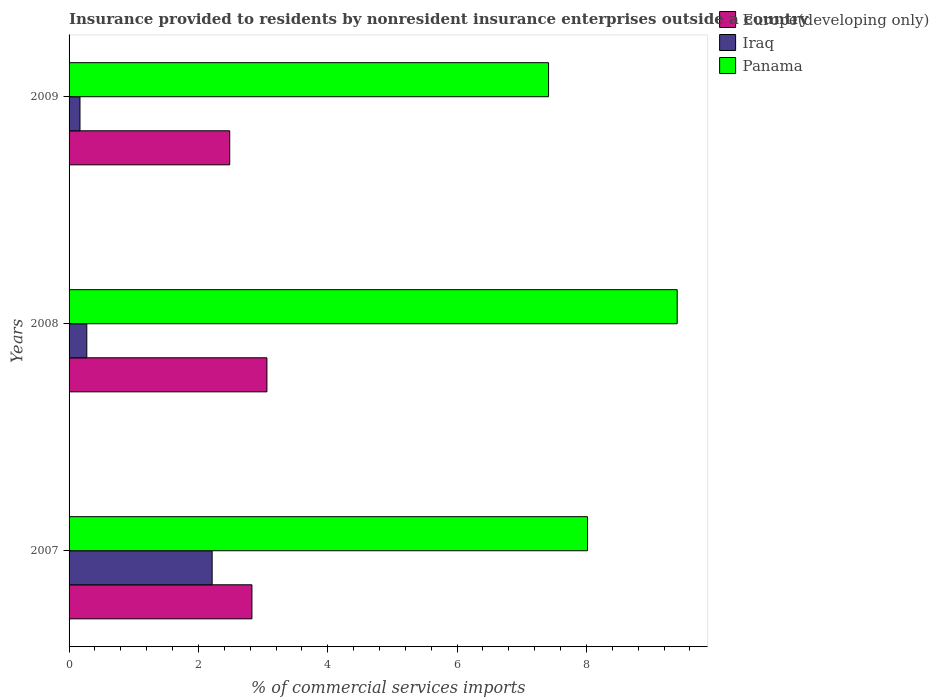How many different coloured bars are there?
Offer a very short reply. 3. Are the number of bars on each tick of the Y-axis equal?
Offer a terse response. Yes. How many bars are there on the 2nd tick from the top?
Make the answer very short. 3. What is the Insurance provided to residents in Panama in 2008?
Offer a very short reply. 9.4. Across all years, what is the maximum Insurance provided to residents in Europe(developing only)?
Keep it short and to the point. 3.06. Across all years, what is the minimum Insurance provided to residents in Panama?
Ensure brevity in your answer.  7.41. In which year was the Insurance provided to residents in Iraq maximum?
Offer a terse response. 2007. In which year was the Insurance provided to residents in Europe(developing only) minimum?
Your answer should be compact. 2009. What is the total Insurance provided to residents in Panama in the graph?
Provide a short and direct response. 24.83. What is the difference between the Insurance provided to residents in Iraq in 2007 and that in 2009?
Keep it short and to the point. 2.04. What is the difference between the Insurance provided to residents in Panama in 2009 and the Insurance provided to residents in Iraq in 2007?
Ensure brevity in your answer.  5.2. What is the average Insurance provided to residents in Iraq per year?
Make the answer very short. 0.88. In the year 2008, what is the difference between the Insurance provided to residents in Panama and Insurance provided to residents in Europe(developing only)?
Your response must be concise. 6.34. What is the ratio of the Insurance provided to residents in Panama in 2008 to that in 2009?
Your response must be concise. 1.27. Is the difference between the Insurance provided to residents in Panama in 2008 and 2009 greater than the difference between the Insurance provided to residents in Europe(developing only) in 2008 and 2009?
Make the answer very short. Yes. What is the difference between the highest and the second highest Insurance provided to residents in Europe(developing only)?
Give a very brief answer. 0.23. What is the difference between the highest and the lowest Insurance provided to residents in Panama?
Your answer should be compact. 1.99. In how many years, is the Insurance provided to residents in Panama greater than the average Insurance provided to residents in Panama taken over all years?
Ensure brevity in your answer.  1. What does the 2nd bar from the top in 2009 represents?
Your response must be concise. Iraq. What does the 2nd bar from the bottom in 2008 represents?
Provide a succinct answer. Iraq. Are all the bars in the graph horizontal?
Your answer should be very brief. Yes. How many years are there in the graph?
Your response must be concise. 3. What is the difference between two consecutive major ticks on the X-axis?
Keep it short and to the point. 2. What is the title of the graph?
Your response must be concise. Insurance provided to residents by nonresident insurance enterprises outside a country. Does "North America" appear as one of the legend labels in the graph?
Make the answer very short. No. What is the label or title of the X-axis?
Provide a short and direct response. % of commercial services imports. What is the label or title of the Y-axis?
Make the answer very short. Years. What is the % of commercial services imports of Europe(developing only) in 2007?
Ensure brevity in your answer.  2.83. What is the % of commercial services imports of Iraq in 2007?
Ensure brevity in your answer.  2.21. What is the % of commercial services imports in Panama in 2007?
Ensure brevity in your answer.  8.02. What is the % of commercial services imports of Europe(developing only) in 2008?
Give a very brief answer. 3.06. What is the % of commercial services imports of Iraq in 2008?
Your answer should be compact. 0.27. What is the % of commercial services imports in Panama in 2008?
Your response must be concise. 9.4. What is the % of commercial services imports of Europe(developing only) in 2009?
Keep it short and to the point. 2.48. What is the % of commercial services imports of Iraq in 2009?
Offer a very short reply. 0.17. What is the % of commercial services imports of Panama in 2009?
Offer a very short reply. 7.41. Across all years, what is the maximum % of commercial services imports in Europe(developing only)?
Make the answer very short. 3.06. Across all years, what is the maximum % of commercial services imports in Iraq?
Your answer should be very brief. 2.21. Across all years, what is the maximum % of commercial services imports in Panama?
Your answer should be compact. 9.4. Across all years, what is the minimum % of commercial services imports of Europe(developing only)?
Your answer should be very brief. 2.48. Across all years, what is the minimum % of commercial services imports of Iraq?
Provide a succinct answer. 0.17. Across all years, what is the minimum % of commercial services imports of Panama?
Your answer should be very brief. 7.41. What is the total % of commercial services imports in Europe(developing only) in the graph?
Ensure brevity in your answer.  8.37. What is the total % of commercial services imports of Iraq in the graph?
Give a very brief answer. 2.65. What is the total % of commercial services imports in Panama in the graph?
Provide a succinct answer. 24.83. What is the difference between the % of commercial services imports of Europe(developing only) in 2007 and that in 2008?
Make the answer very short. -0.23. What is the difference between the % of commercial services imports in Iraq in 2007 and that in 2008?
Provide a succinct answer. 1.94. What is the difference between the % of commercial services imports of Panama in 2007 and that in 2008?
Give a very brief answer. -1.39. What is the difference between the % of commercial services imports in Europe(developing only) in 2007 and that in 2009?
Give a very brief answer. 0.34. What is the difference between the % of commercial services imports of Iraq in 2007 and that in 2009?
Offer a terse response. 2.04. What is the difference between the % of commercial services imports in Panama in 2007 and that in 2009?
Keep it short and to the point. 0.6. What is the difference between the % of commercial services imports in Europe(developing only) in 2008 and that in 2009?
Keep it short and to the point. 0.58. What is the difference between the % of commercial services imports of Iraq in 2008 and that in 2009?
Provide a succinct answer. 0.11. What is the difference between the % of commercial services imports in Panama in 2008 and that in 2009?
Provide a short and direct response. 1.99. What is the difference between the % of commercial services imports in Europe(developing only) in 2007 and the % of commercial services imports in Iraq in 2008?
Ensure brevity in your answer.  2.55. What is the difference between the % of commercial services imports of Europe(developing only) in 2007 and the % of commercial services imports of Panama in 2008?
Make the answer very short. -6.58. What is the difference between the % of commercial services imports in Iraq in 2007 and the % of commercial services imports in Panama in 2008?
Keep it short and to the point. -7.19. What is the difference between the % of commercial services imports in Europe(developing only) in 2007 and the % of commercial services imports in Iraq in 2009?
Ensure brevity in your answer.  2.66. What is the difference between the % of commercial services imports of Europe(developing only) in 2007 and the % of commercial services imports of Panama in 2009?
Provide a short and direct response. -4.59. What is the difference between the % of commercial services imports in Iraq in 2007 and the % of commercial services imports in Panama in 2009?
Provide a succinct answer. -5.2. What is the difference between the % of commercial services imports of Europe(developing only) in 2008 and the % of commercial services imports of Iraq in 2009?
Give a very brief answer. 2.89. What is the difference between the % of commercial services imports of Europe(developing only) in 2008 and the % of commercial services imports of Panama in 2009?
Your answer should be compact. -4.35. What is the difference between the % of commercial services imports in Iraq in 2008 and the % of commercial services imports in Panama in 2009?
Offer a terse response. -7.14. What is the average % of commercial services imports in Europe(developing only) per year?
Your answer should be very brief. 2.79. What is the average % of commercial services imports in Iraq per year?
Offer a terse response. 0.89. What is the average % of commercial services imports of Panama per year?
Your answer should be very brief. 8.28. In the year 2007, what is the difference between the % of commercial services imports of Europe(developing only) and % of commercial services imports of Iraq?
Keep it short and to the point. 0.62. In the year 2007, what is the difference between the % of commercial services imports in Europe(developing only) and % of commercial services imports in Panama?
Your answer should be compact. -5.19. In the year 2007, what is the difference between the % of commercial services imports of Iraq and % of commercial services imports of Panama?
Keep it short and to the point. -5.8. In the year 2008, what is the difference between the % of commercial services imports in Europe(developing only) and % of commercial services imports in Iraq?
Offer a terse response. 2.79. In the year 2008, what is the difference between the % of commercial services imports of Europe(developing only) and % of commercial services imports of Panama?
Offer a terse response. -6.34. In the year 2008, what is the difference between the % of commercial services imports of Iraq and % of commercial services imports of Panama?
Your answer should be very brief. -9.13. In the year 2009, what is the difference between the % of commercial services imports of Europe(developing only) and % of commercial services imports of Iraq?
Make the answer very short. 2.32. In the year 2009, what is the difference between the % of commercial services imports of Europe(developing only) and % of commercial services imports of Panama?
Ensure brevity in your answer.  -4.93. In the year 2009, what is the difference between the % of commercial services imports of Iraq and % of commercial services imports of Panama?
Make the answer very short. -7.25. What is the ratio of the % of commercial services imports in Europe(developing only) in 2007 to that in 2008?
Offer a terse response. 0.92. What is the ratio of the % of commercial services imports of Iraq in 2007 to that in 2008?
Provide a short and direct response. 8.07. What is the ratio of the % of commercial services imports of Panama in 2007 to that in 2008?
Provide a short and direct response. 0.85. What is the ratio of the % of commercial services imports of Europe(developing only) in 2007 to that in 2009?
Keep it short and to the point. 1.14. What is the ratio of the % of commercial services imports of Iraq in 2007 to that in 2009?
Provide a succinct answer. 13.11. What is the ratio of the % of commercial services imports in Panama in 2007 to that in 2009?
Offer a very short reply. 1.08. What is the ratio of the % of commercial services imports in Europe(developing only) in 2008 to that in 2009?
Your answer should be compact. 1.23. What is the ratio of the % of commercial services imports in Iraq in 2008 to that in 2009?
Provide a short and direct response. 1.62. What is the ratio of the % of commercial services imports of Panama in 2008 to that in 2009?
Provide a short and direct response. 1.27. What is the difference between the highest and the second highest % of commercial services imports in Europe(developing only)?
Offer a terse response. 0.23. What is the difference between the highest and the second highest % of commercial services imports of Iraq?
Provide a succinct answer. 1.94. What is the difference between the highest and the second highest % of commercial services imports in Panama?
Keep it short and to the point. 1.39. What is the difference between the highest and the lowest % of commercial services imports of Europe(developing only)?
Make the answer very short. 0.58. What is the difference between the highest and the lowest % of commercial services imports in Iraq?
Provide a succinct answer. 2.04. What is the difference between the highest and the lowest % of commercial services imports in Panama?
Give a very brief answer. 1.99. 